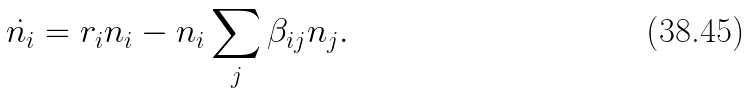Convert formula to latex. <formula><loc_0><loc_0><loc_500><loc_500>\dot { n _ { i } } = r _ { i } n _ { i } - n _ { i } \sum _ { j } \beta _ { i j } n _ { j } .</formula> 